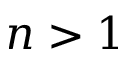<formula> <loc_0><loc_0><loc_500><loc_500>n > 1</formula> 